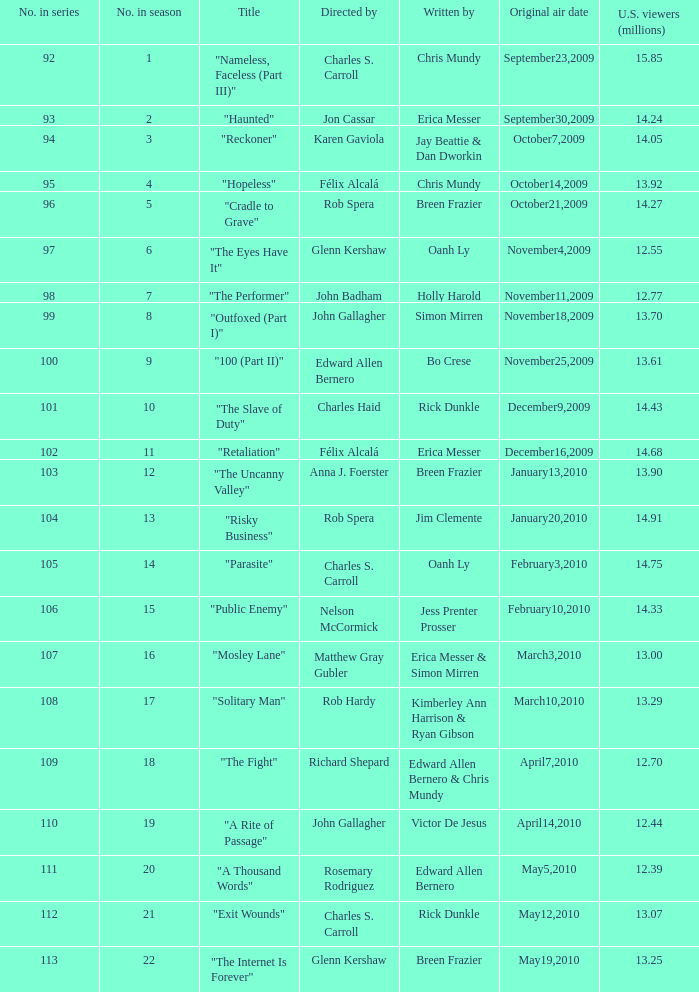Who wrote episode number 109 in the series? Edward Allen Bernero & Chris Mundy. 